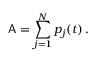<formula> <loc_0><loc_0><loc_500><loc_500>A = \sum _ { j = 1 } ^ { N } p _ { j } ( t ) \, .</formula> 